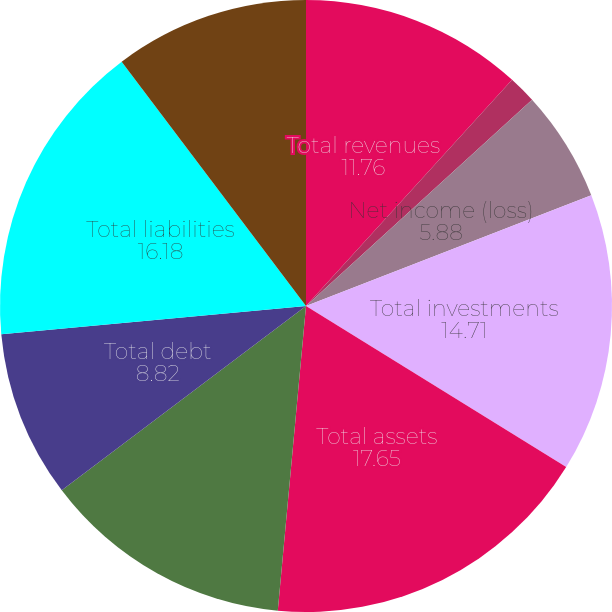<chart> <loc_0><loc_0><loc_500><loc_500><pie_chart><fcel>Total revenues<fcel>Income from continuing<fcel>Net income (loss)<fcel>Total investments<fcel>Total assets<fcel>Claims and claim adjustment<fcel>Total debt<fcel>Total liabilities<fcel>Total shareholders' equity<nl><fcel>11.76%<fcel>1.47%<fcel>5.88%<fcel>14.71%<fcel>17.65%<fcel>13.24%<fcel>8.82%<fcel>16.18%<fcel>10.29%<nl></chart> 